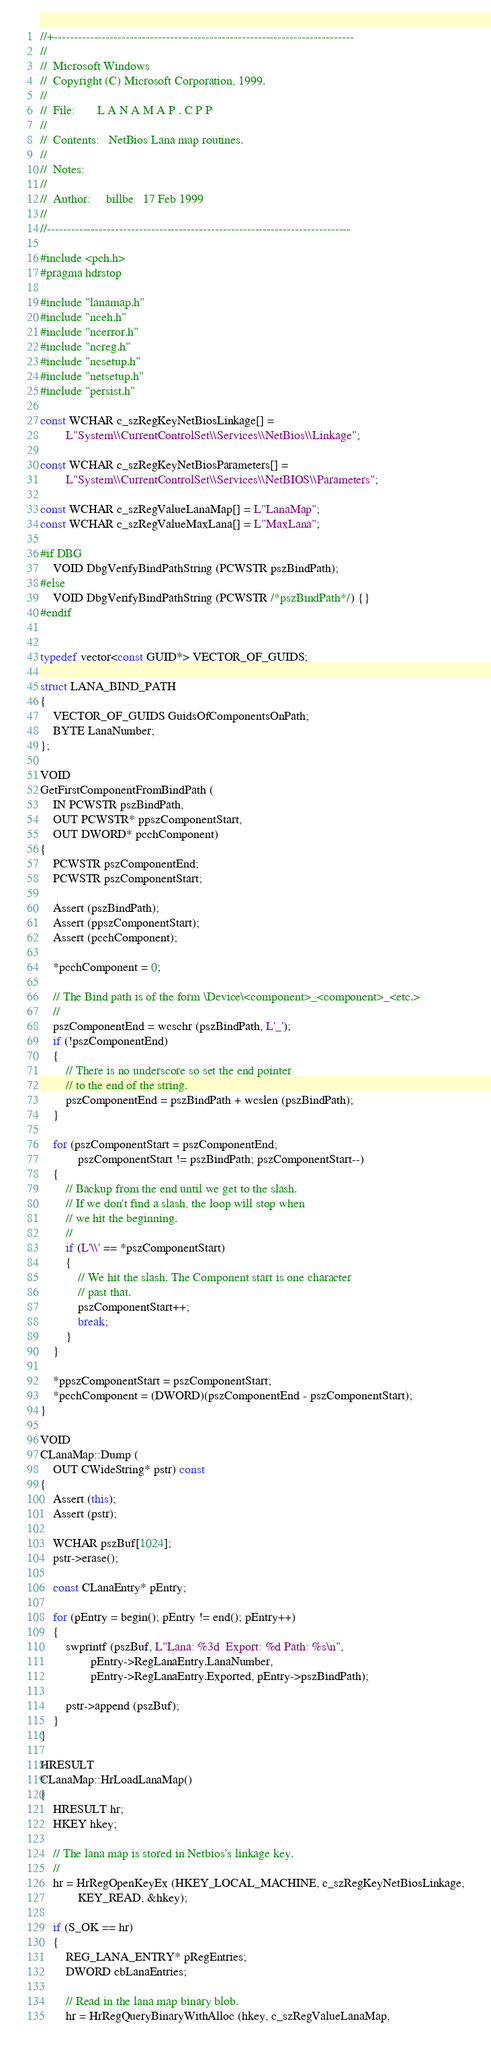Convert code to text. <code><loc_0><loc_0><loc_500><loc_500><_C++_>//+---------------------------------------------------------------------------
//
//  Microsoft Windows
//  Copyright (C) Microsoft Corporation, 1999.
//
//  File:       L A N A M A P . C P P
//
//  Contents:   NetBios Lana map routines.
//
//  Notes:
//
//  Author:     billbe   17 Feb 1999
//
//----------------------------------------------------------------------------

#include <pch.h>
#pragma hdrstop

#include "lanamap.h"
#include "nceh.h"
#include "ncerror.h"
#include "ncreg.h"
#include "ncsetup.h"
#include "netsetup.h"
#include "persist.h"

const WCHAR c_szRegKeyNetBiosLinkage[] =
        L"System\\CurrentControlSet\\Services\\NetBios\\Linkage";

const WCHAR c_szRegKeyNetBiosParameters[] =
        L"System\\CurrentControlSet\\Services\\NetBIOS\\Parameters";

const WCHAR c_szRegValueLanaMap[] = L"LanaMap";
const WCHAR c_szRegValueMaxLana[] = L"MaxLana";

#if DBG
    VOID DbgVerifyBindPathString (PCWSTR pszBindPath);
#else
    VOID DbgVerifyBindPathString (PCWSTR /*pszBindPath*/) {}
#endif


typedef vector<const GUID*> VECTOR_OF_GUIDS;

struct LANA_BIND_PATH
{
    VECTOR_OF_GUIDS GuidsOfComponentsOnPath;
    BYTE LanaNumber;
};

VOID
GetFirstComponentFromBindPath (
    IN PCWSTR pszBindPath,
    OUT PCWSTR* ppszComponentStart,
    OUT DWORD* pcchComponent)
{
    PCWSTR pszComponentEnd;
    PCWSTR pszComponentStart;

    Assert (pszBindPath);
    Assert (ppszComponentStart);
    Assert (pcchComponent);

    *pcchComponent = 0;

    // The Bind path is of the form \Device\<component>_<component>_<etc.>
    //
    pszComponentEnd = wcschr (pszBindPath, L'_');
    if (!pszComponentEnd)
    {
        // There is no underscore so set the end pointer
        // to the end of the string.
        pszComponentEnd = pszBindPath + wcslen (pszBindPath);
    }

    for (pszComponentStart = pszComponentEnd;
            pszComponentStart != pszBindPath; pszComponentStart--)
    {
        // Backup from the end until we get to the slash.
        // If we don't find a slash, the loop will stop when
        // we hit the beginning.
        //
        if (L'\\' == *pszComponentStart)
        {
            // We hit the slash. The Component start is one character
            // past that.
            pszComponentStart++;
            break;
        }
    }

    *ppszComponentStart = pszComponentStart;
    *pcchComponent = (DWORD)(pszComponentEnd - pszComponentStart);
}

VOID
CLanaMap::Dump (
    OUT CWideString* pstr) const
{
    Assert (this);
    Assert (pstr);

    WCHAR pszBuf[1024];
    pstr->erase();

    const CLanaEntry* pEntry;

    for (pEntry = begin(); pEntry != end(); pEntry++)
    {
        swprintf (pszBuf, L"Lana: %3d  Export: %d Path: %s\n",
                pEntry->RegLanaEntry.LanaNumber,
                pEntry->RegLanaEntry.Exported, pEntry->pszBindPath);

        pstr->append (pszBuf);
    }
}

HRESULT
CLanaMap::HrLoadLanaMap()
{
    HRESULT hr;
    HKEY hkey;

    // The lana map is stored in Netbios's linkage key.
    //
    hr = HrRegOpenKeyEx (HKEY_LOCAL_MACHINE, c_szRegKeyNetBiosLinkage,
            KEY_READ, &hkey);

    if (S_OK == hr)
    {
        REG_LANA_ENTRY* pRegEntries;
        DWORD cbLanaEntries;

        // Read in the lana map binary blob.
        hr = HrRegQueryBinaryWithAlloc (hkey, c_szRegValueLanaMap,</code> 